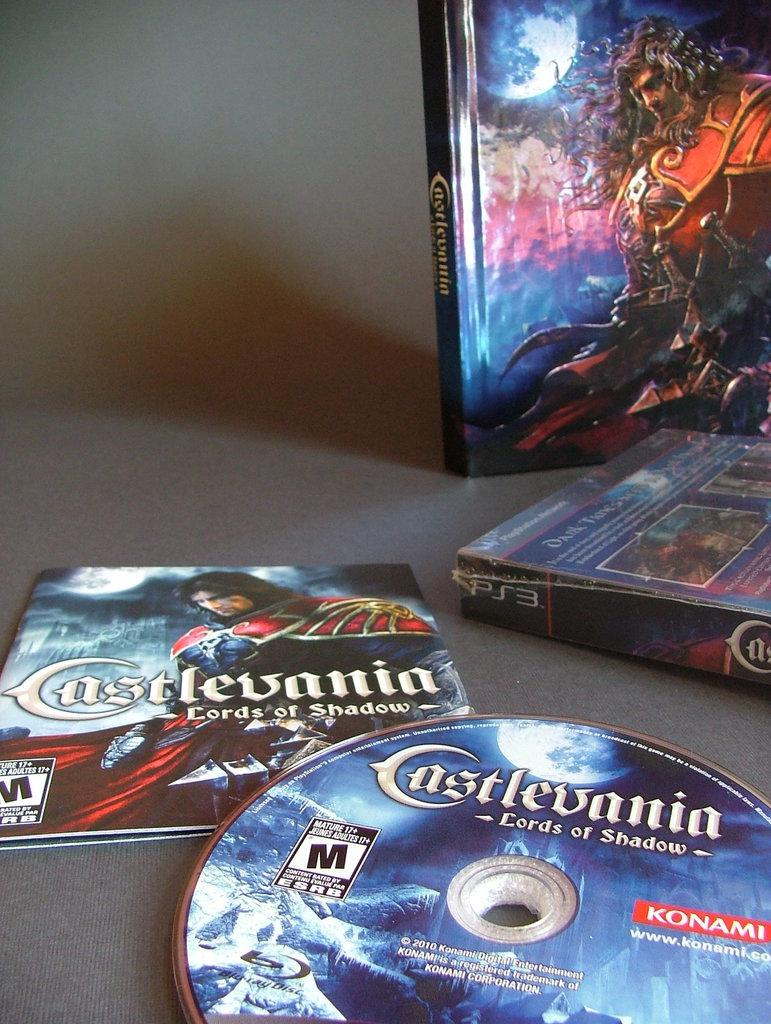What is the main object in the image? There is a disc in the image. What else can be seen in the image besides the disc? There are cases and a book with pictures and text in the image. Where are these objects placed? All these objects are placed on a surface. How does the island contribute to the overall theme of the image? There is no island present in the image; it only features a disc, cases, and a book. 